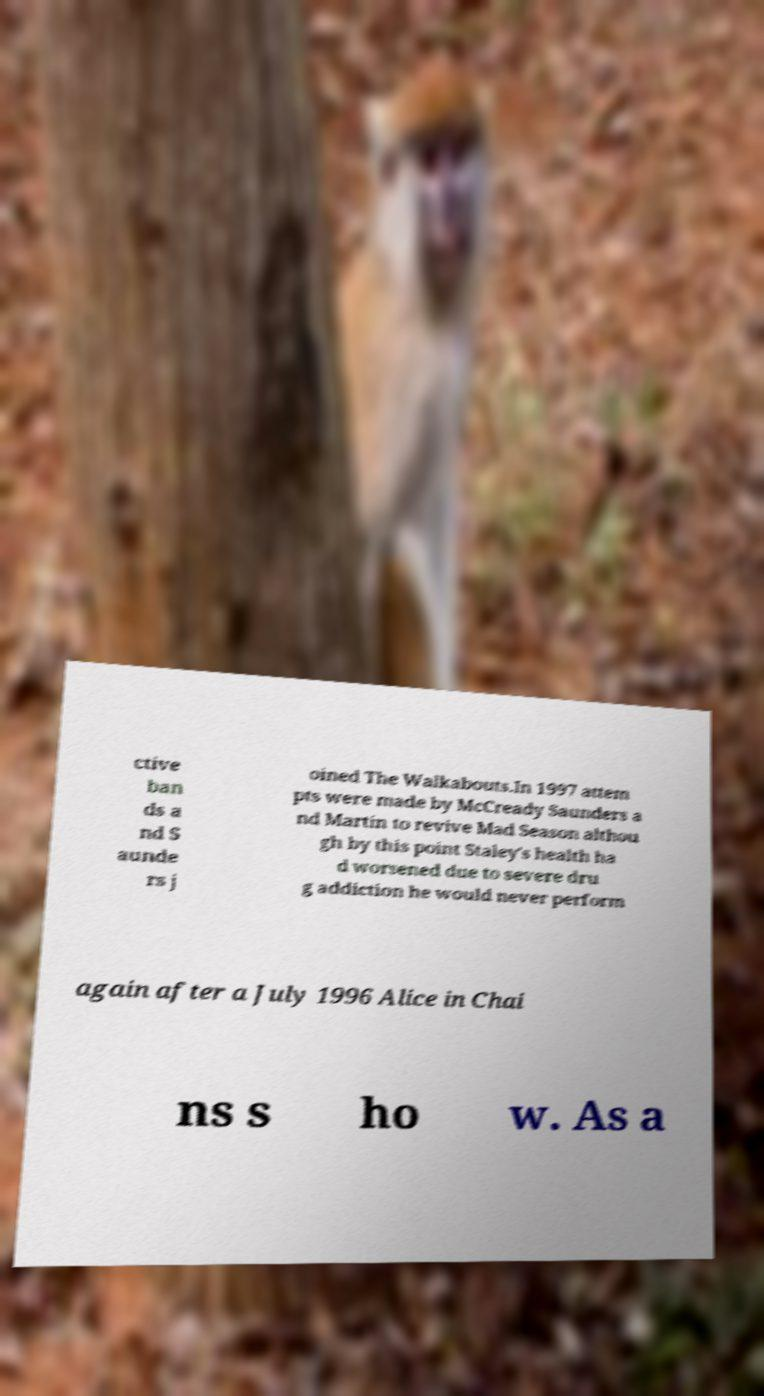There's text embedded in this image that I need extracted. Can you transcribe it verbatim? ctive ban ds a nd S aunde rs j oined The Walkabouts.In 1997 attem pts were made by McCready Saunders a nd Martin to revive Mad Season althou gh by this point Staley's health ha d worsened due to severe dru g addiction he would never perform again after a July 1996 Alice in Chai ns s ho w. As a 